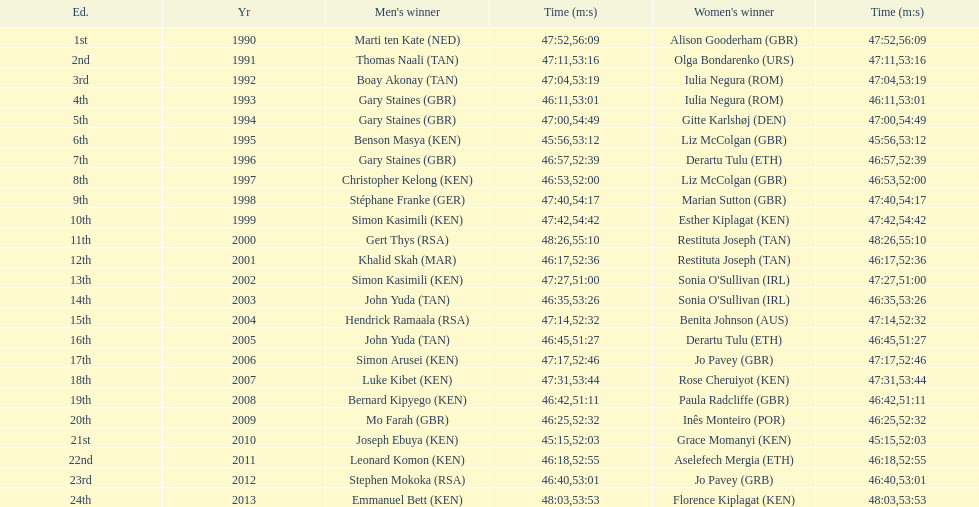Home many times did a single country win both the men's and women's bupa great south run? 4. 